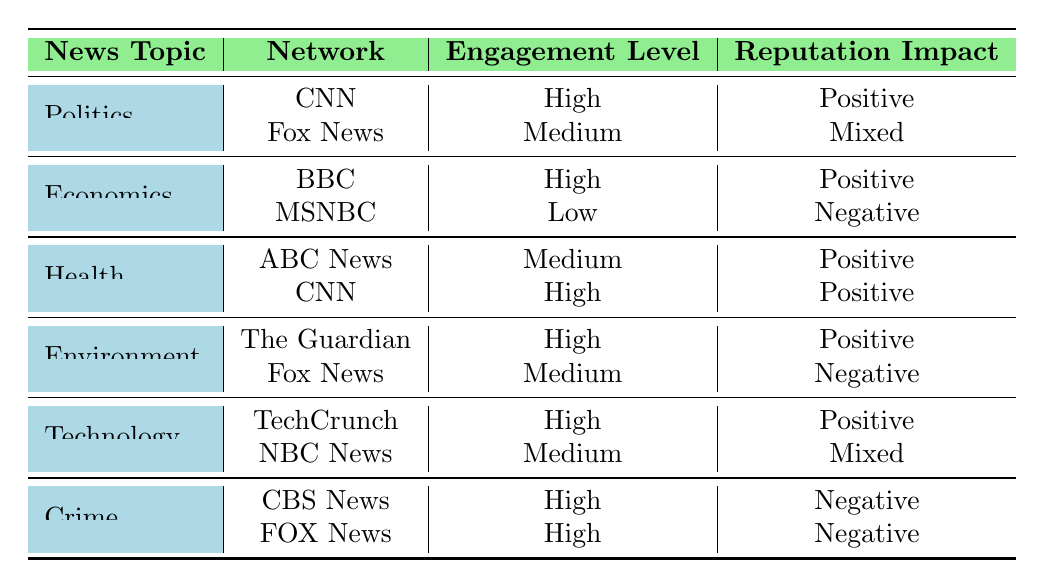What is the engagement level for CNN in the Politics topic? The table specifies that CNN has a "High" engagement level for the Politics topic.
Answer: High Which network has a negative reputation impact in the Economics topic? According to the table, MSNBC has a "Low" engagement level and a "Negative" reputation impact in the Economics topic.
Answer: MSNBC How many networks show a positive reputation impact in the Health topic? The table lists two networks (ABC News and CNN) with a "Positive" reputation impact in the Health topic.
Answer: 2 Is it true that both networks have a high engagement level in the Crime topic? The table indicates that both CBS News and FOX News have a "High" engagement level in the Crime topic. Therefore, the statement is true.
Answer: Yes What is the average engagement level across all topics listed for CNN? CNN has a "High" engagement level in both Politics and Health, categorized as a value of 2. As CNN does not participate in other topics, the average engagement level is (2 + 2) / 2 = 2. However, there are 5 different engagement levels (High, Medium, Low) on a scale of 1 to 3 (with High as 3, Medium as 2, and Low as 1), resulting in an average of 2 (considering participation across their two active topics).
Answer: 2 